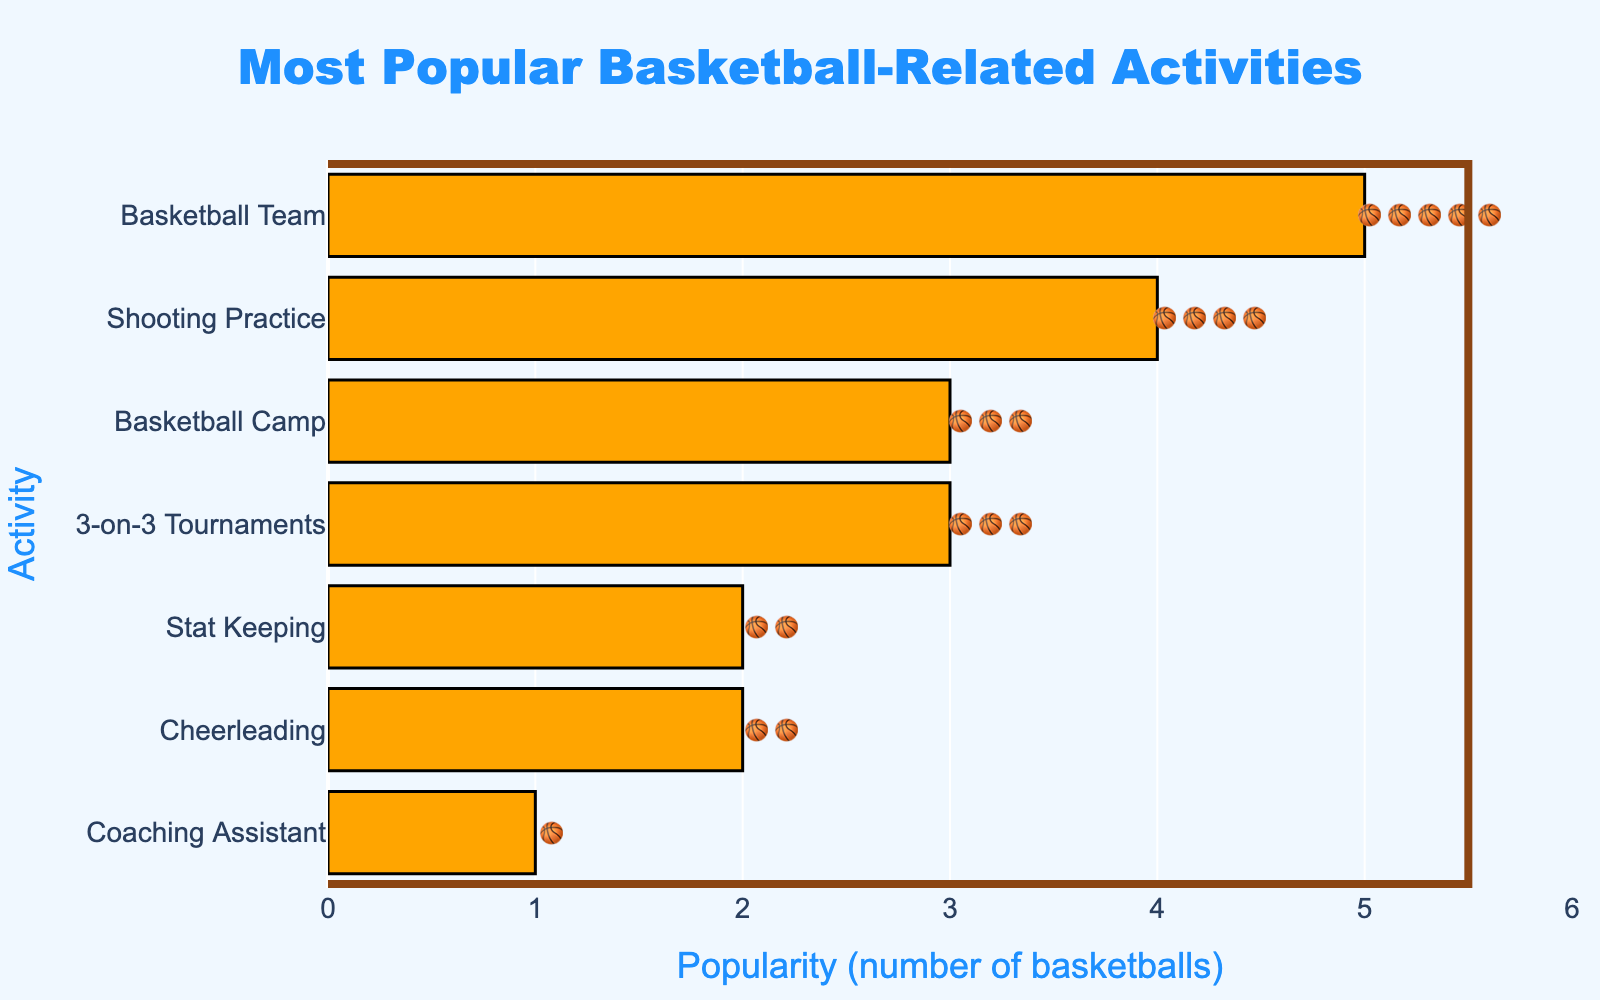What is the title of the figure? The title is displayed at the top of the figure, and it reads 'Most Popular Basketball-Related Activities'.
Answer: Most Popular Basketball-Related Activities How many activities are displayed in the figure? The total number of bars or rows in the figure represents the number of activities. There are seven rows, so there are seven activities displayed.
Answer: 7 Which activity is the most popular based on the chart? The activity with the longest bar and the most basketball emojis is the most popular. The 'Basketball Team' has the longest bar and the most emojis (🏀🏀🏀🏀🏀).
Answer: Basketball Team Which activity has the least popularity? The activity with the shortest bar and the least basketball emojis is the least popular. The 'Coaching Assistant' has the shortest bar and the least emojis (🏀).
Answer: Coaching Assistant What is the difference in popularity between the 'Basketball Team' and the 'Cheerleading' activities? 'Basketball Team' has 5 basketball emojis and 'Cheerleading' has 2 basketballs. The difference in popularity is 5 - 2 = 3 basketballs.
Answer: 3 How many activities have a popularity of three basketballs or more? Count the activities with a popularity of three emojis or more. 'Basketball Team' (5), 'Shooting Practice' (4), '3-on-3 Tournaments' (3), and 'Basketball Camp' (3) have three or more. There are four such activities.
Answer: 4 Which activity has exactly two basketball emojis? Look for the activity with exactly two emojis. 'Cheerleading' and 'Stat Keeping' have exactly two basketball emojis each.
Answer: Cheerleading and Stat Keeping 